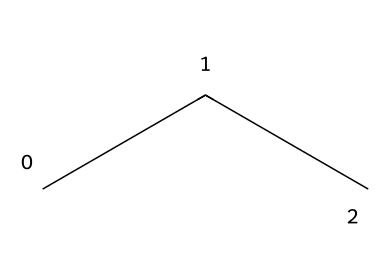What is the molecular formula of propane? The SMILES representation "CCC" indicates three carbon atoms (C) and eight hydrogen atoms (H). This is derived from the fact that each carbon can bond with enough hydrogen to satisfy the tetravalent nature of carbon. Thus, the molecular formula can be deduced as C3H8.
Answer: C3H8 How many hydrogen atoms are in propane? To determine the number of hydrogen atoms, we can analyze the SMILES representation "CCC". Each carbon can bond with hydrogen atoms to form a stable compound. In propane, there are 3 carbon atoms and, following the general formula for aliphatic hydrocarbons, the number of hydrogen atoms is 2n + 2 (where n is the number of carbon atoms), resulting in 8 hydrogen atoms for 3 carbon atoms.
Answer: 8 What type of compound is propane? Propane is classified as an alkane, which is determined by its molecular structure showing only single bonds between carbon atoms. Alkanes are a specific category of aliphatic compounds that contain carbon and hydrogen only, with single bonds.
Answer: alkane How many bonds are there between the carbon atoms in propane? In the structure represented by the SMILES "CCC", there are two carbon-carbon single bonds connecting the three carbon atoms. Each bond serves to link one carbon to another in a chain without any double or triple bonding present.
Answer: 2 Is propane a saturated or unsaturated hydrocarbon? From the SMILES "CCC", we see that propane has only single bonds connecting the carbon atoms, which confirms it has the maximum number of hydrogen atoms per carbon. This characteristic defines it as a saturated hydrocarbon.
Answer: saturated What is the common use of propane in camping? Propane is commonly used as a fuel source for portable stoves and heaters in camping. Its high energy content and ability to be stored in liquid form make it ideal for these applications, providing efficient heat for cooking and warmth.
Answer: fuel 